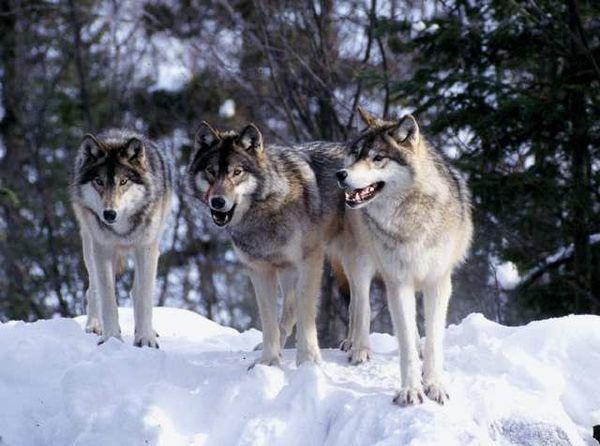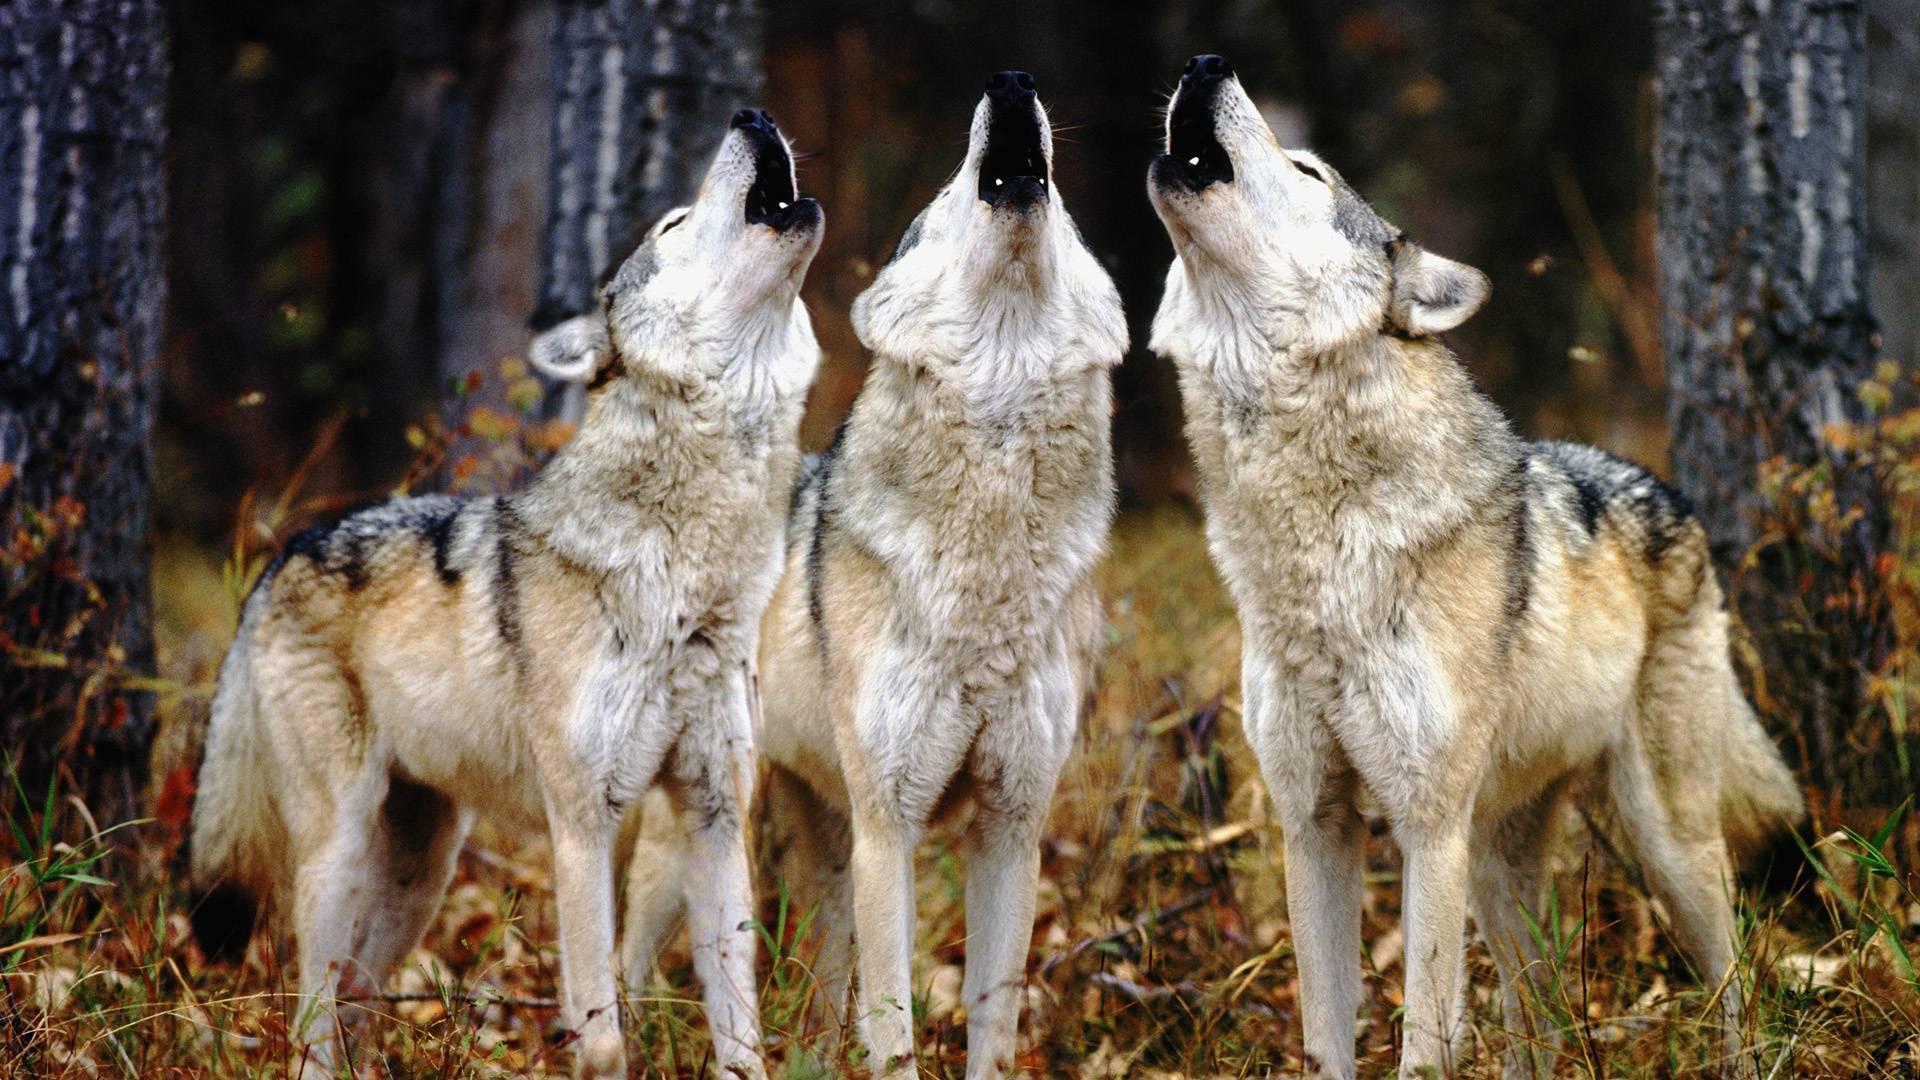The first image is the image on the left, the second image is the image on the right. Evaluate the accuracy of this statement regarding the images: "The image on the right contains exactly one black wolf". Is it true? Answer yes or no. No. The first image is the image on the left, the second image is the image on the right. Examine the images to the left and right. Is the description "The image on the right contains one wolf with a black colored head." accurate? Answer yes or no. No. 